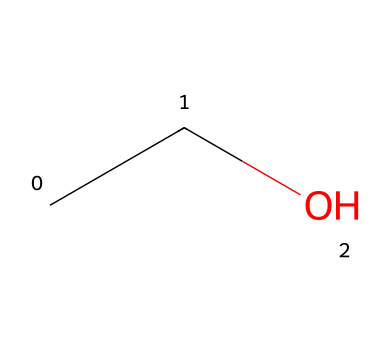What is the name of this chemical? The SMILES representation "CCO" corresponds to a molecule with two carbon atoms followed by an oxygen atom, which is known as ethanol.
Answer: ethanol How many carbon atoms are in ethanol? The SMILES shows "CC," meaning there are two carbon atoms in the structure of ethanol.
Answer: two What is the functional group present in ethanol? Ethanol has an -OH (hydroxyl) group bonded to one of the carbon atoms, indicating it is an alcohol.
Answer: alcohol What is the molecular formula of ethanol? By analyzing the structure, ethanol consists of two carbon atoms, six hydrogen atoms, and one oxygen atom, leading to the molecular formula C2H6O.
Answer: C2H6O Is ethanol a polar solvent? The presence of the hydroxyl (-OH) group in ethanol makes it polar due to its ability to form hydrogen bonds with water.
Answer: yes How many hydrogen bonds can an ethanol molecule typically form? Each hydroxyl group can participate in hydrogen bonding, and since ethanol has one such group, it can typically form up to three hydrogen bonds per molecule (one with itself and two with water).
Answer: three What role does ethanol play in tinctures? Ethanol serves as a solvent in tinctures due to its ability to dissolve various plant compounds and facilitate extraction efficiently.
Answer: solvent 